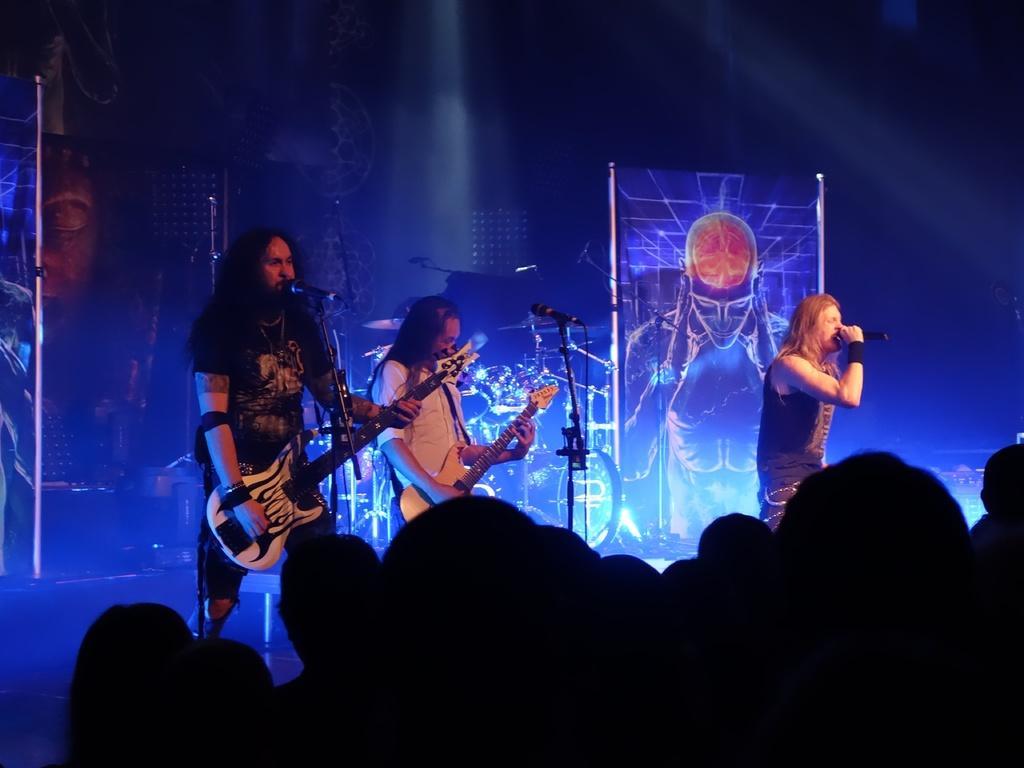Can you describe this image briefly? There are group of musicians in this image performing on the stage. The man at the right side is holding a mic and singing. In the center man is holding guitar in his hand and playing it. And the left side the person standing is holding a guitar in his hand and singing in front of the mic. In the background there are boards. In the front the crowd is enjoying the concert. 